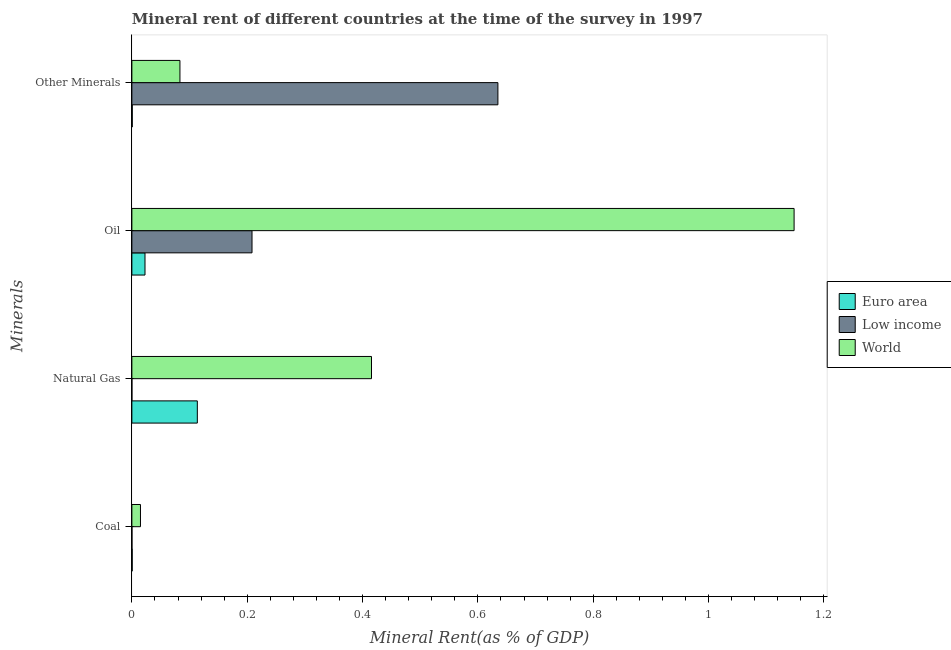How many groups of bars are there?
Provide a short and direct response. 4. Are the number of bars per tick equal to the number of legend labels?
Give a very brief answer. Yes. Are the number of bars on each tick of the Y-axis equal?
Your answer should be compact. Yes. What is the label of the 4th group of bars from the top?
Keep it short and to the point. Coal. What is the coal rent in Low income?
Give a very brief answer. 0. Across all countries, what is the maximum  rent of other minerals?
Offer a terse response. 0.63. Across all countries, what is the minimum natural gas rent?
Provide a short and direct response. 3.83841350463664e-5. What is the total  rent of other minerals in the graph?
Make the answer very short. 0.72. What is the difference between the oil rent in World and that in Euro area?
Provide a succinct answer. 1.13. What is the difference between the  rent of other minerals in World and the natural gas rent in Euro area?
Your answer should be compact. -0.03. What is the average oil rent per country?
Your answer should be very brief. 0.46. What is the difference between the  rent of other minerals and oil rent in Euro area?
Provide a short and direct response. -0.02. What is the ratio of the natural gas rent in World to that in Low income?
Your answer should be compact. 1.08e+04. Is the oil rent in World less than that in Euro area?
Make the answer very short. No. Is the difference between the coal rent in World and Euro area greater than the difference between the oil rent in World and Euro area?
Make the answer very short. No. What is the difference between the highest and the second highest coal rent?
Give a very brief answer. 0.01. What is the difference between the highest and the lowest natural gas rent?
Offer a very short reply. 0.42. Is it the case that in every country, the sum of the oil rent and natural gas rent is greater than the sum of  rent of other minerals and coal rent?
Provide a short and direct response. No. Is it the case that in every country, the sum of the coal rent and natural gas rent is greater than the oil rent?
Keep it short and to the point. No. How many bars are there?
Make the answer very short. 12. Are the values on the major ticks of X-axis written in scientific E-notation?
Your answer should be very brief. No. Does the graph contain grids?
Your answer should be very brief. No. What is the title of the graph?
Offer a terse response. Mineral rent of different countries at the time of the survey in 1997. What is the label or title of the X-axis?
Your answer should be very brief. Mineral Rent(as % of GDP). What is the label or title of the Y-axis?
Provide a short and direct response. Minerals. What is the Mineral Rent(as % of GDP) in Euro area in Coal?
Your answer should be very brief. 0. What is the Mineral Rent(as % of GDP) in Low income in Coal?
Provide a short and direct response. 0. What is the Mineral Rent(as % of GDP) of World in Coal?
Provide a short and direct response. 0.01. What is the Mineral Rent(as % of GDP) of Euro area in Natural Gas?
Your response must be concise. 0.11. What is the Mineral Rent(as % of GDP) of Low income in Natural Gas?
Provide a short and direct response. 3.83841350463664e-5. What is the Mineral Rent(as % of GDP) of World in Natural Gas?
Offer a terse response. 0.42. What is the Mineral Rent(as % of GDP) in Euro area in Oil?
Make the answer very short. 0.02. What is the Mineral Rent(as % of GDP) of Low income in Oil?
Offer a very short reply. 0.21. What is the Mineral Rent(as % of GDP) in World in Oil?
Offer a very short reply. 1.15. What is the Mineral Rent(as % of GDP) in Euro area in Other Minerals?
Provide a short and direct response. 0. What is the Mineral Rent(as % of GDP) in Low income in Other Minerals?
Your answer should be very brief. 0.63. What is the Mineral Rent(as % of GDP) in World in Other Minerals?
Offer a terse response. 0.08. Across all Minerals, what is the maximum Mineral Rent(as % of GDP) of Euro area?
Ensure brevity in your answer.  0.11. Across all Minerals, what is the maximum Mineral Rent(as % of GDP) of Low income?
Offer a very short reply. 0.63. Across all Minerals, what is the maximum Mineral Rent(as % of GDP) in World?
Your answer should be very brief. 1.15. Across all Minerals, what is the minimum Mineral Rent(as % of GDP) in Euro area?
Your response must be concise. 0. Across all Minerals, what is the minimum Mineral Rent(as % of GDP) of Low income?
Make the answer very short. 3.83841350463664e-5. Across all Minerals, what is the minimum Mineral Rent(as % of GDP) of World?
Offer a terse response. 0.01. What is the total Mineral Rent(as % of GDP) in Euro area in the graph?
Give a very brief answer. 0.14. What is the total Mineral Rent(as % of GDP) in Low income in the graph?
Your response must be concise. 0.84. What is the total Mineral Rent(as % of GDP) of World in the graph?
Offer a very short reply. 1.66. What is the difference between the Mineral Rent(as % of GDP) in Euro area in Coal and that in Natural Gas?
Make the answer very short. -0.11. What is the difference between the Mineral Rent(as % of GDP) of Low income in Coal and that in Natural Gas?
Provide a succinct answer. 0. What is the difference between the Mineral Rent(as % of GDP) of World in Coal and that in Natural Gas?
Offer a very short reply. -0.4. What is the difference between the Mineral Rent(as % of GDP) in Euro area in Coal and that in Oil?
Your answer should be compact. -0.02. What is the difference between the Mineral Rent(as % of GDP) in Low income in Coal and that in Oil?
Provide a succinct answer. -0.21. What is the difference between the Mineral Rent(as % of GDP) in World in Coal and that in Oil?
Give a very brief answer. -1.13. What is the difference between the Mineral Rent(as % of GDP) in Euro area in Coal and that in Other Minerals?
Your response must be concise. -0. What is the difference between the Mineral Rent(as % of GDP) of Low income in Coal and that in Other Minerals?
Keep it short and to the point. -0.63. What is the difference between the Mineral Rent(as % of GDP) of World in Coal and that in Other Minerals?
Keep it short and to the point. -0.07. What is the difference between the Mineral Rent(as % of GDP) of Euro area in Natural Gas and that in Oil?
Make the answer very short. 0.09. What is the difference between the Mineral Rent(as % of GDP) in Low income in Natural Gas and that in Oil?
Keep it short and to the point. -0.21. What is the difference between the Mineral Rent(as % of GDP) of World in Natural Gas and that in Oil?
Your answer should be compact. -0.73. What is the difference between the Mineral Rent(as % of GDP) of Euro area in Natural Gas and that in Other Minerals?
Provide a succinct answer. 0.11. What is the difference between the Mineral Rent(as % of GDP) of Low income in Natural Gas and that in Other Minerals?
Give a very brief answer. -0.63. What is the difference between the Mineral Rent(as % of GDP) in World in Natural Gas and that in Other Minerals?
Provide a succinct answer. 0.33. What is the difference between the Mineral Rent(as % of GDP) of Euro area in Oil and that in Other Minerals?
Your response must be concise. 0.02. What is the difference between the Mineral Rent(as % of GDP) in Low income in Oil and that in Other Minerals?
Provide a succinct answer. -0.43. What is the difference between the Mineral Rent(as % of GDP) in World in Oil and that in Other Minerals?
Your answer should be very brief. 1.06. What is the difference between the Mineral Rent(as % of GDP) of Euro area in Coal and the Mineral Rent(as % of GDP) of World in Natural Gas?
Make the answer very short. -0.41. What is the difference between the Mineral Rent(as % of GDP) in Low income in Coal and the Mineral Rent(as % of GDP) in World in Natural Gas?
Ensure brevity in your answer.  -0.42. What is the difference between the Mineral Rent(as % of GDP) of Euro area in Coal and the Mineral Rent(as % of GDP) of Low income in Oil?
Your answer should be very brief. -0.21. What is the difference between the Mineral Rent(as % of GDP) in Euro area in Coal and the Mineral Rent(as % of GDP) in World in Oil?
Offer a terse response. -1.15. What is the difference between the Mineral Rent(as % of GDP) in Low income in Coal and the Mineral Rent(as % of GDP) in World in Oil?
Provide a short and direct response. -1.15. What is the difference between the Mineral Rent(as % of GDP) of Euro area in Coal and the Mineral Rent(as % of GDP) of Low income in Other Minerals?
Your response must be concise. -0.63. What is the difference between the Mineral Rent(as % of GDP) in Euro area in Coal and the Mineral Rent(as % of GDP) in World in Other Minerals?
Your answer should be compact. -0.08. What is the difference between the Mineral Rent(as % of GDP) of Low income in Coal and the Mineral Rent(as % of GDP) of World in Other Minerals?
Your answer should be very brief. -0.08. What is the difference between the Mineral Rent(as % of GDP) in Euro area in Natural Gas and the Mineral Rent(as % of GDP) in Low income in Oil?
Provide a succinct answer. -0.09. What is the difference between the Mineral Rent(as % of GDP) of Euro area in Natural Gas and the Mineral Rent(as % of GDP) of World in Oil?
Ensure brevity in your answer.  -1.03. What is the difference between the Mineral Rent(as % of GDP) of Low income in Natural Gas and the Mineral Rent(as % of GDP) of World in Oil?
Keep it short and to the point. -1.15. What is the difference between the Mineral Rent(as % of GDP) in Euro area in Natural Gas and the Mineral Rent(as % of GDP) in Low income in Other Minerals?
Give a very brief answer. -0.52. What is the difference between the Mineral Rent(as % of GDP) in Euro area in Natural Gas and the Mineral Rent(as % of GDP) in World in Other Minerals?
Your answer should be compact. 0.03. What is the difference between the Mineral Rent(as % of GDP) in Low income in Natural Gas and the Mineral Rent(as % of GDP) in World in Other Minerals?
Keep it short and to the point. -0.08. What is the difference between the Mineral Rent(as % of GDP) in Euro area in Oil and the Mineral Rent(as % of GDP) in Low income in Other Minerals?
Your answer should be very brief. -0.61. What is the difference between the Mineral Rent(as % of GDP) of Euro area in Oil and the Mineral Rent(as % of GDP) of World in Other Minerals?
Make the answer very short. -0.06. What is the difference between the Mineral Rent(as % of GDP) in Low income in Oil and the Mineral Rent(as % of GDP) in World in Other Minerals?
Your answer should be very brief. 0.12. What is the average Mineral Rent(as % of GDP) in Euro area per Minerals?
Your answer should be very brief. 0.03. What is the average Mineral Rent(as % of GDP) in Low income per Minerals?
Give a very brief answer. 0.21. What is the average Mineral Rent(as % of GDP) in World per Minerals?
Your answer should be very brief. 0.42. What is the difference between the Mineral Rent(as % of GDP) in Euro area and Mineral Rent(as % of GDP) in Low income in Coal?
Provide a succinct answer. 0. What is the difference between the Mineral Rent(as % of GDP) in Euro area and Mineral Rent(as % of GDP) in World in Coal?
Provide a succinct answer. -0.01. What is the difference between the Mineral Rent(as % of GDP) in Low income and Mineral Rent(as % of GDP) in World in Coal?
Your answer should be compact. -0.01. What is the difference between the Mineral Rent(as % of GDP) in Euro area and Mineral Rent(as % of GDP) in Low income in Natural Gas?
Your answer should be compact. 0.11. What is the difference between the Mineral Rent(as % of GDP) of Euro area and Mineral Rent(as % of GDP) of World in Natural Gas?
Provide a short and direct response. -0.3. What is the difference between the Mineral Rent(as % of GDP) of Low income and Mineral Rent(as % of GDP) of World in Natural Gas?
Make the answer very short. -0.42. What is the difference between the Mineral Rent(as % of GDP) of Euro area and Mineral Rent(as % of GDP) of Low income in Oil?
Your answer should be compact. -0.19. What is the difference between the Mineral Rent(as % of GDP) of Euro area and Mineral Rent(as % of GDP) of World in Oil?
Ensure brevity in your answer.  -1.13. What is the difference between the Mineral Rent(as % of GDP) in Low income and Mineral Rent(as % of GDP) in World in Oil?
Give a very brief answer. -0.94. What is the difference between the Mineral Rent(as % of GDP) in Euro area and Mineral Rent(as % of GDP) in Low income in Other Minerals?
Your response must be concise. -0.63. What is the difference between the Mineral Rent(as % of GDP) of Euro area and Mineral Rent(as % of GDP) of World in Other Minerals?
Provide a succinct answer. -0.08. What is the difference between the Mineral Rent(as % of GDP) in Low income and Mineral Rent(as % of GDP) in World in Other Minerals?
Make the answer very short. 0.55. What is the ratio of the Mineral Rent(as % of GDP) in Euro area in Coal to that in Natural Gas?
Provide a short and direct response. 0.01. What is the ratio of the Mineral Rent(as % of GDP) in Low income in Coal to that in Natural Gas?
Make the answer very short. 3.22. What is the ratio of the Mineral Rent(as % of GDP) in World in Coal to that in Natural Gas?
Make the answer very short. 0.04. What is the ratio of the Mineral Rent(as % of GDP) in Euro area in Coal to that in Oil?
Offer a terse response. 0.03. What is the ratio of the Mineral Rent(as % of GDP) in Low income in Coal to that in Oil?
Keep it short and to the point. 0. What is the ratio of the Mineral Rent(as % of GDP) of World in Coal to that in Oil?
Provide a succinct answer. 0.01. What is the ratio of the Mineral Rent(as % of GDP) in Euro area in Coal to that in Other Minerals?
Provide a succinct answer. 0.83. What is the ratio of the Mineral Rent(as % of GDP) of World in Coal to that in Other Minerals?
Give a very brief answer. 0.18. What is the ratio of the Mineral Rent(as % of GDP) in Euro area in Natural Gas to that in Oil?
Give a very brief answer. 4.99. What is the ratio of the Mineral Rent(as % of GDP) of Low income in Natural Gas to that in Oil?
Your answer should be compact. 0. What is the ratio of the Mineral Rent(as % of GDP) in World in Natural Gas to that in Oil?
Your answer should be very brief. 0.36. What is the ratio of the Mineral Rent(as % of GDP) of Euro area in Natural Gas to that in Other Minerals?
Offer a very short reply. 164.93. What is the ratio of the Mineral Rent(as % of GDP) of World in Natural Gas to that in Other Minerals?
Offer a terse response. 4.99. What is the ratio of the Mineral Rent(as % of GDP) in Euro area in Oil to that in Other Minerals?
Make the answer very short. 33.06. What is the ratio of the Mineral Rent(as % of GDP) of Low income in Oil to that in Other Minerals?
Keep it short and to the point. 0.33. What is the ratio of the Mineral Rent(as % of GDP) in World in Oil to that in Other Minerals?
Provide a short and direct response. 13.78. What is the difference between the highest and the second highest Mineral Rent(as % of GDP) of Euro area?
Make the answer very short. 0.09. What is the difference between the highest and the second highest Mineral Rent(as % of GDP) of Low income?
Keep it short and to the point. 0.43. What is the difference between the highest and the second highest Mineral Rent(as % of GDP) in World?
Offer a terse response. 0.73. What is the difference between the highest and the lowest Mineral Rent(as % of GDP) in Euro area?
Your response must be concise. 0.11. What is the difference between the highest and the lowest Mineral Rent(as % of GDP) in Low income?
Make the answer very short. 0.63. What is the difference between the highest and the lowest Mineral Rent(as % of GDP) in World?
Offer a terse response. 1.13. 